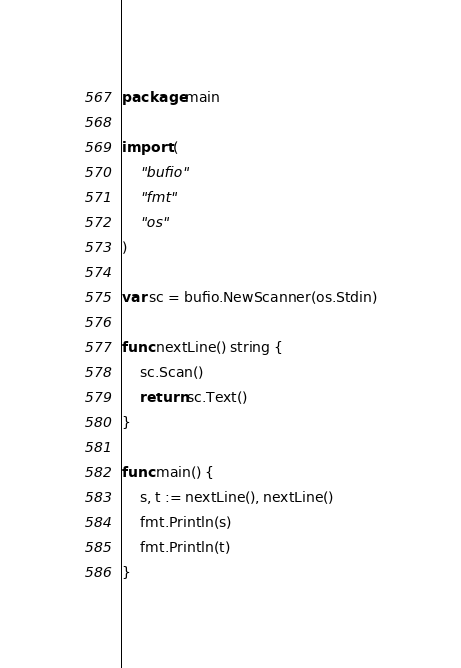<code> <loc_0><loc_0><loc_500><loc_500><_Go_>package main

import (
    "bufio"
    "fmt"
    "os"
)

var sc = bufio.NewScanner(os.Stdin)

func nextLine() string {
    sc.Scan()
    return sc.Text()
}

func main() {
    s, t := nextLine(), nextLine()
    fmt.Println(s)
    fmt.Println(t)
}</code> 